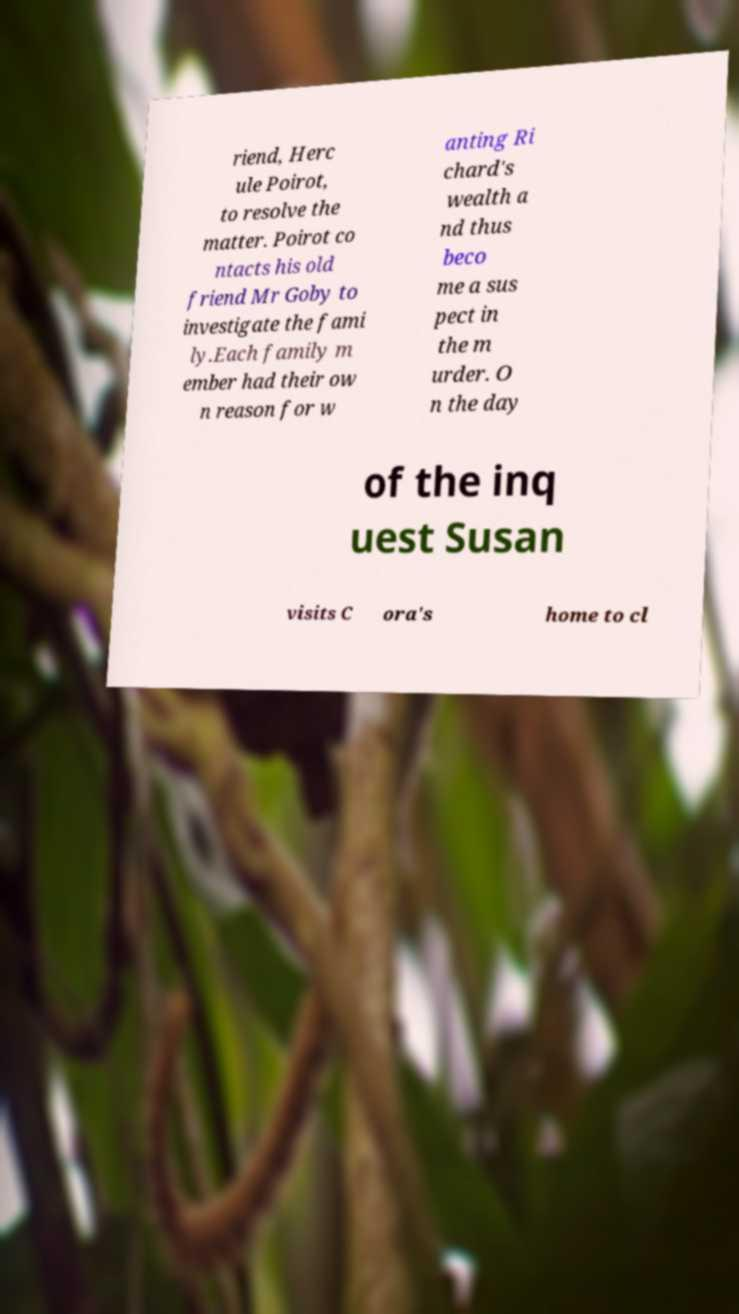For documentation purposes, I need the text within this image transcribed. Could you provide that? riend, Herc ule Poirot, to resolve the matter. Poirot co ntacts his old friend Mr Goby to investigate the fami ly.Each family m ember had their ow n reason for w anting Ri chard's wealth a nd thus beco me a sus pect in the m urder. O n the day of the inq uest Susan visits C ora's home to cl 